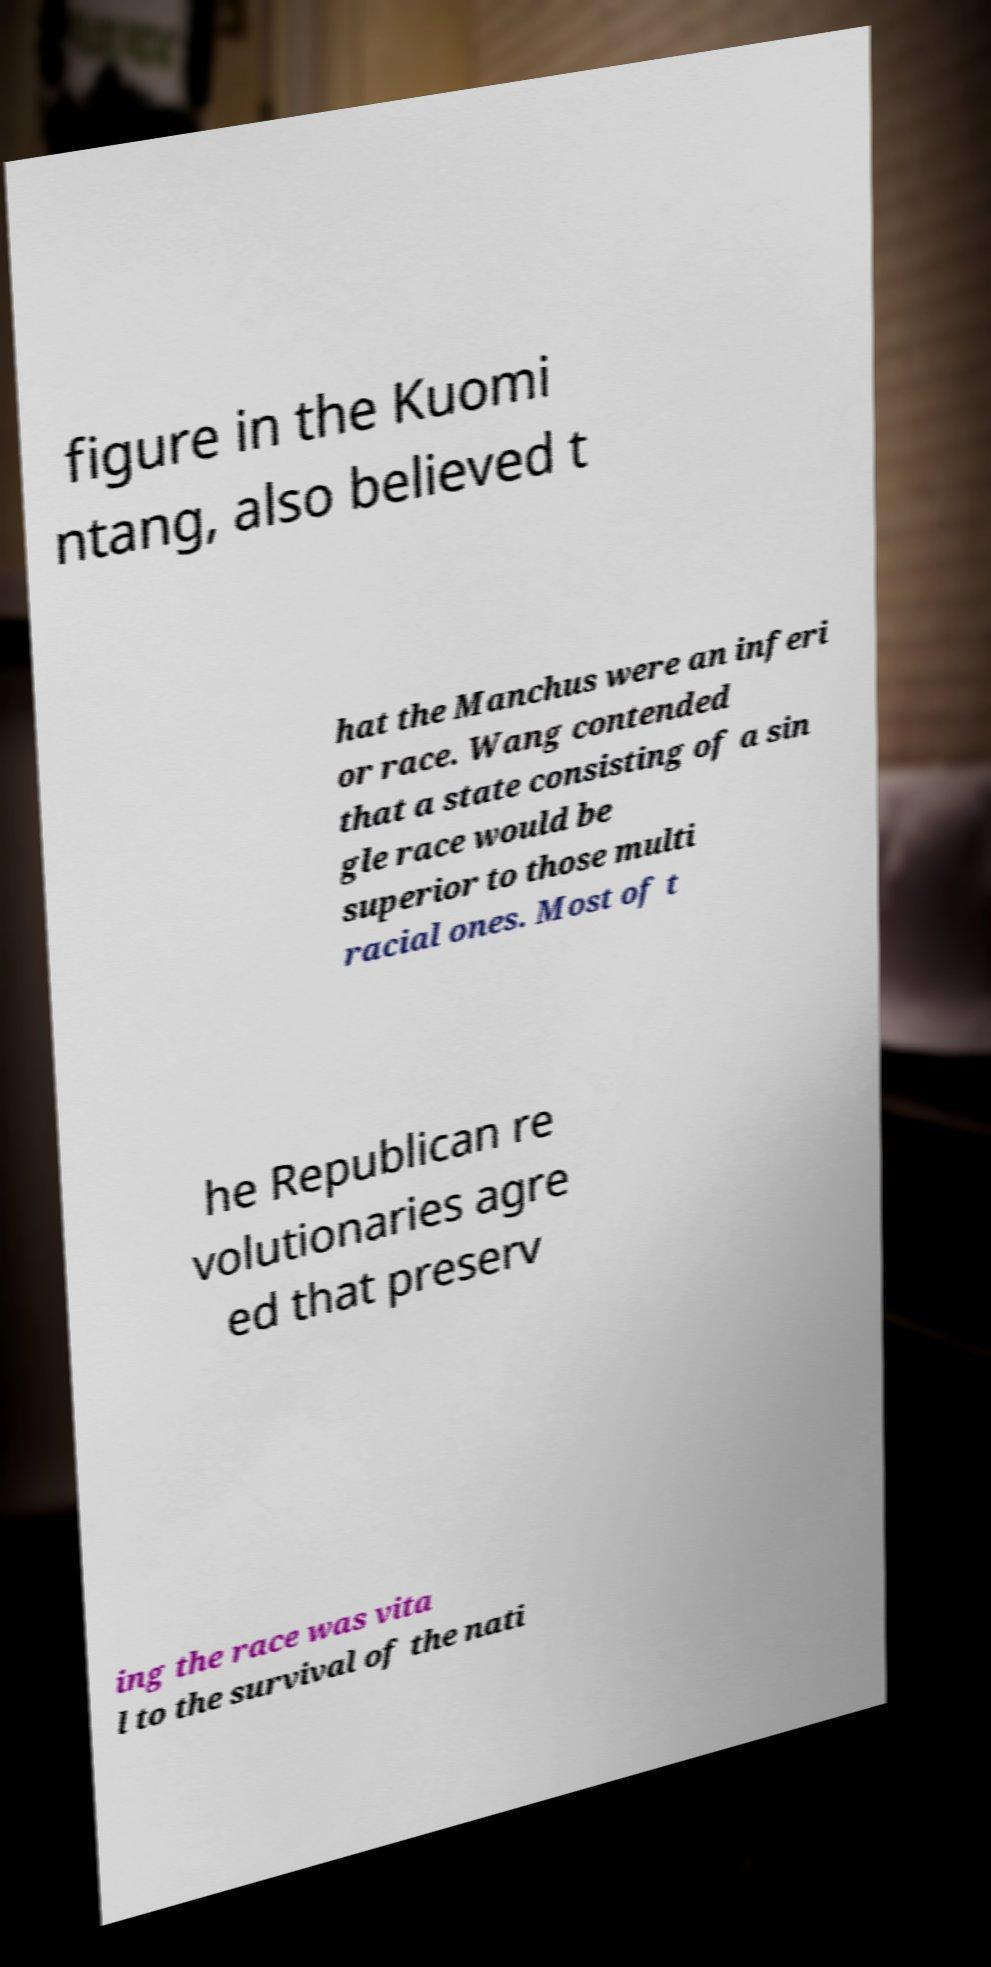What messages or text are displayed in this image? I need them in a readable, typed format. figure in the Kuomi ntang, also believed t hat the Manchus were an inferi or race. Wang contended that a state consisting of a sin gle race would be superior to those multi racial ones. Most of t he Republican re volutionaries agre ed that preserv ing the race was vita l to the survival of the nati 